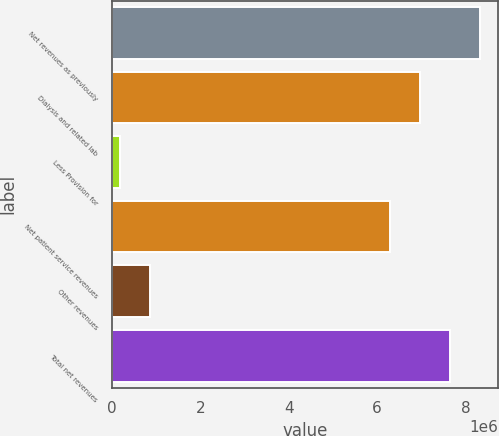Convert chart to OTSL. <chart><loc_0><loc_0><loc_500><loc_500><bar_chart><fcel>Net revenues as previously<fcel>Dialysis and related lab<fcel>Less Provision for<fcel>Net patient service revenues<fcel>Other revenues<fcel>Total net revenues<nl><fcel>8.3179e+06<fcel>6.9595e+06<fcel>190234<fcel>6.28031e+06<fcel>869432<fcel>7.6387e+06<nl></chart> 